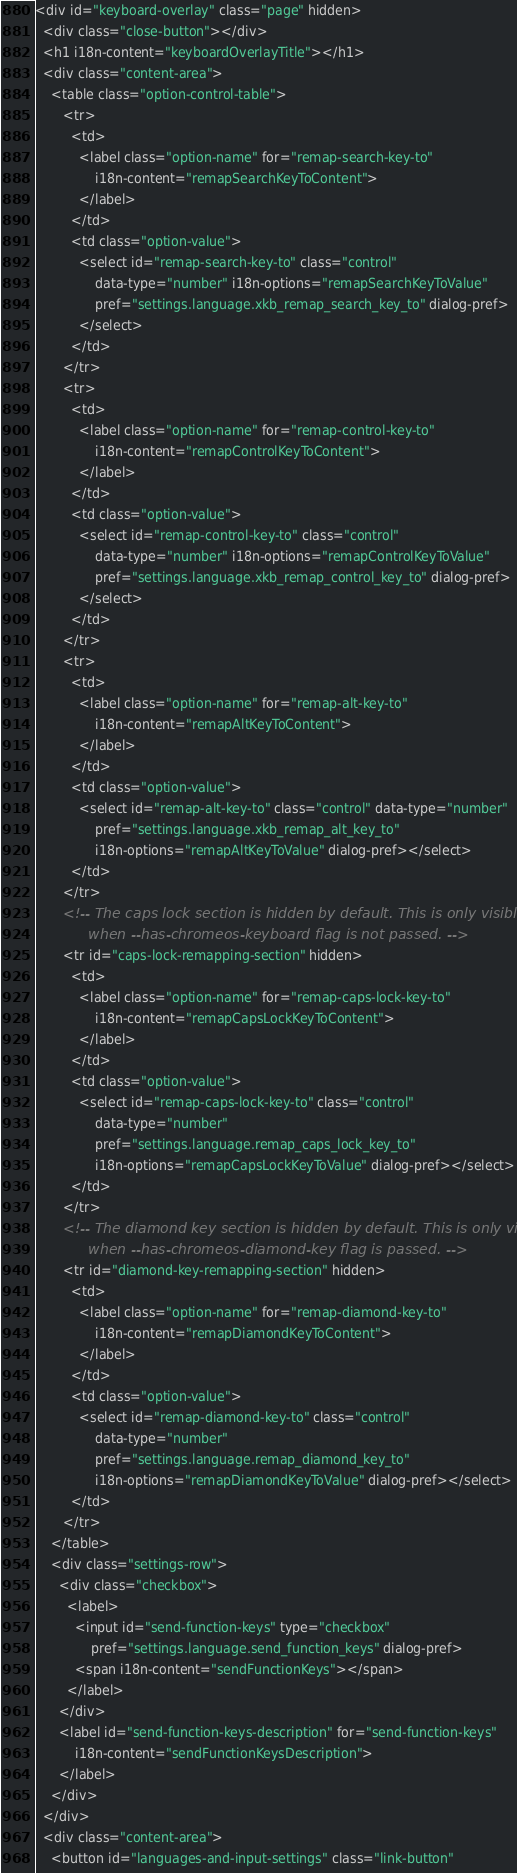<code> <loc_0><loc_0><loc_500><loc_500><_HTML_><div id="keyboard-overlay" class="page" hidden>
  <div class="close-button"></div>
  <h1 i18n-content="keyboardOverlayTitle"></h1>
  <div class="content-area">
    <table class="option-control-table">
       <tr>
         <td>
           <label class="option-name" for="remap-search-key-to"
               i18n-content="remapSearchKeyToContent">
           </label>
         </td>
         <td class="option-value">
           <select id="remap-search-key-to" class="control"
               data-type="number" i18n-options="remapSearchKeyToValue"
               pref="settings.language.xkb_remap_search_key_to" dialog-pref>
           </select>
         </td>
       </tr>
       <tr>
         <td>
           <label class="option-name" for="remap-control-key-to"
               i18n-content="remapControlKeyToContent">
           </label>
         </td>
         <td class="option-value">
           <select id="remap-control-key-to" class="control"
               data-type="number" i18n-options="remapControlKeyToValue"
               pref="settings.language.xkb_remap_control_key_to" dialog-pref>
           </select>
         </td>
       </tr>
       <tr>
         <td>
           <label class="option-name" for="remap-alt-key-to"
               i18n-content="remapAltKeyToContent">
           </label>
         </td>
         <td class="option-value">
           <select id="remap-alt-key-to" class="control" data-type="number"
               pref="settings.language.xkb_remap_alt_key_to"
               i18n-options="remapAltKeyToValue" dialog-pref></select>
         </td>
       </tr>
       <!-- The caps lock section is hidden by default. This is only visible
            when --has-chromeos-keyboard flag is not passed. -->
       <tr id="caps-lock-remapping-section" hidden>
         <td>
           <label class="option-name" for="remap-caps-lock-key-to"
               i18n-content="remapCapsLockKeyToContent">
           </label>
         </td>
         <td class="option-value">
           <select id="remap-caps-lock-key-to" class="control"
               data-type="number"
               pref="settings.language.remap_caps_lock_key_to"
               i18n-options="remapCapsLockKeyToValue" dialog-pref></select>
         </td>
       </tr>
       <!-- The diamond key section is hidden by default. This is only visible
            when --has-chromeos-diamond-key flag is passed. -->
       <tr id="diamond-key-remapping-section" hidden>
         <td>
           <label class="option-name" for="remap-diamond-key-to"
               i18n-content="remapDiamondKeyToContent">
           </label>
         </td>
         <td class="option-value">
           <select id="remap-diamond-key-to" class="control"
               data-type="number"
               pref="settings.language.remap_diamond_key_to"
               i18n-options="remapDiamondKeyToValue" dialog-pref></select>
         </td>
       </tr>
    </table>
    <div class="settings-row">
      <div class="checkbox">
        <label>
          <input id="send-function-keys" type="checkbox"
              pref="settings.language.send_function_keys" dialog-pref>
          <span i18n-content="sendFunctionKeys"></span>
        </label>
      </div>
      <label id="send-function-keys-description" for="send-function-keys"
          i18n-content="sendFunctionKeysDescription">
      </label>
    </div>
  </div>
  <div class="content-area">
    <button id="languages-and-input-settings" class="link-button"</code> 